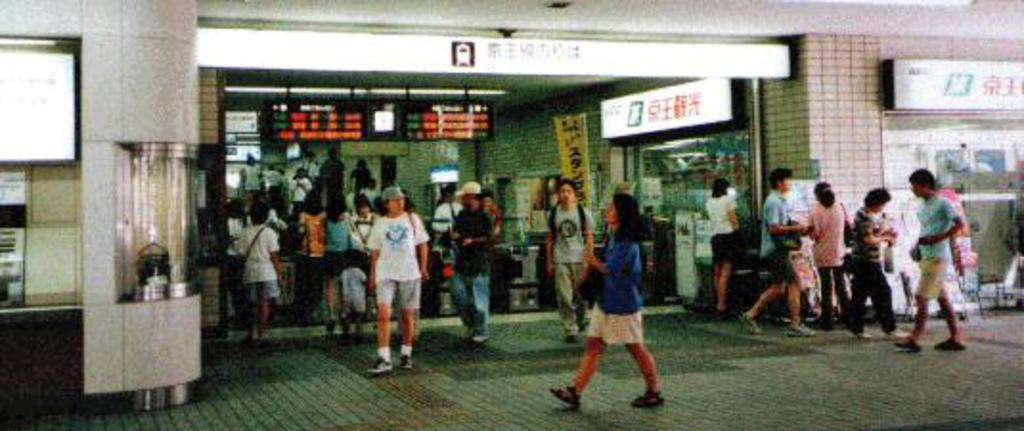What can be seen on the footpath in the image? There are persons on the footpath in the image. How can the persons on the footpath be distinguished from one another? The persons are wearing different color dresses. What is visible in the background of the image? There are hoardings, screens, additional persons, and a building in the background. What type of ornament is being displayed on the disgusting afternoon in the image? There is no ornament or mention of an afternoon in the image, and the term "disgusting" is subjective and not relevant to the image. 